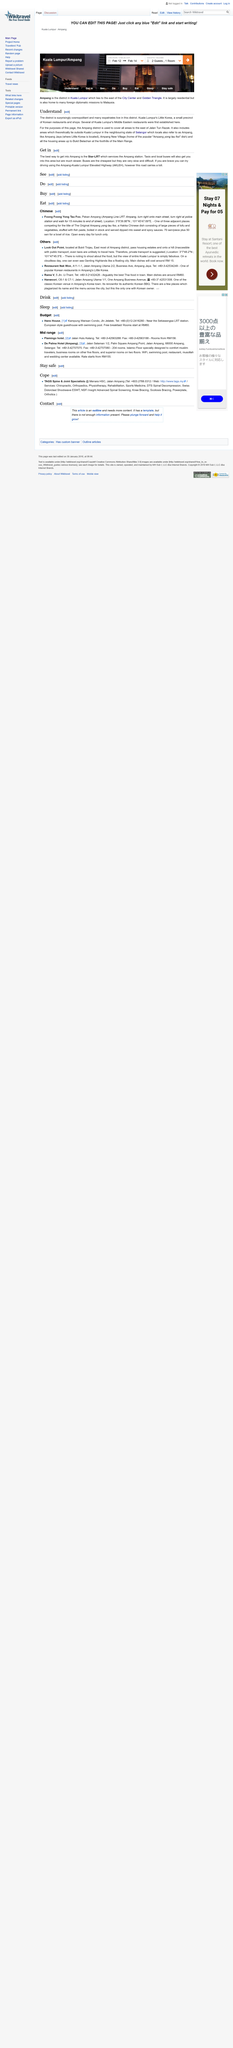Highlight a few significant elements in this photo. The coordinates for Foong Foong Yong Tau Foo are 3 degrees 8 minutes 39.86 seconds north latitude and 101 degrees 45 minutes 47.69 seconds east longitude. The phone number for Rama V is +60-3-21432428. Little Korea is located in the Ampang district. At Rama V, you can savor the most delectable Thai cuisine in town. Several of Kuala Lumpur's first Middle Eastern restaurants were established in Little Korea, which was one of the first neighborhoods in the city to attract a diverse group of immigrants from various regions of the world, including the Middle East. 